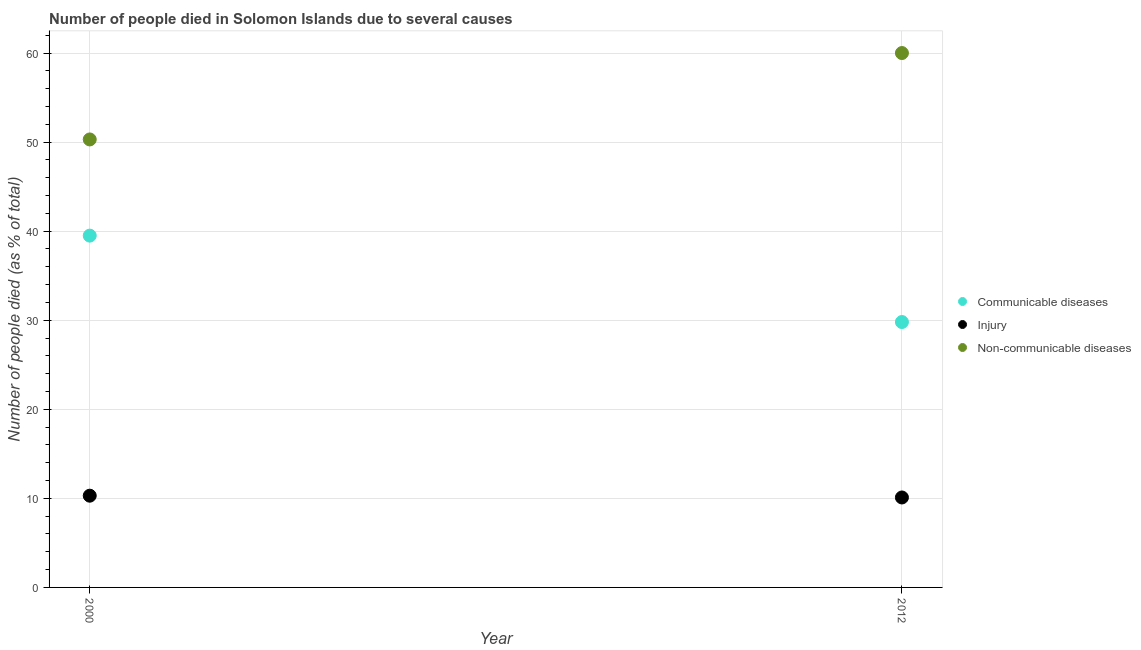How many different coloured dotlines are there?
Ensure brevity in your answer.  3. Is the number of dotlines equal to the number of legend labels?
Keep it short and to the point. Yes. What is the number of people who dies of non-communicable diseases in 2000?
Your answer should be very brief. 50.3. Across all years, what is the maximum number of people who died of injury?
Your answer should be compact. 10.3. Across all years, what is the minimum number of people who died of injury?
Provide a short and direct response. 10.1. In which year was the number of people who died of injury maximum?
Make the answer very short. 2000. In which year was the number of people who died of communicable diseases minimum?
Your answer should be very brief. 2012. What is the total number of people who died of injury in the graph?
Provide a succinct answer. 20.4. What is the difference between the number of people who died of injury in 2000 and that in 2012?
Ensure brevity in your answer.  0.2. What is the average number of people who dies of non-communicable diseases per year?
Provide a short and direct response. 55.15. In the year 2000, what is the difference between the number of people who died of communicable diseases and number of people who dies of non-communicable diseases?
Keep it short and to the point. -10.8. In how many years, is the number of people who dies of non-communicable diseases greater than 34 %?
Keep it short and to the point. 2. What is the ratio of the number of people who died of injury in 2000 to that in 2012?
Your response must be concise. 1.02. Is the number of people who dies of non-communicable diseases in 2000 less than that in 2012?
Your answer should be very brief. Yes. Is it the case that in every year, the sum of the number of people who died of communicable diseases and number of people who died of injury is greater than the number of people who dies of non-communicable diseases?
Keep it short and to the point. No. Does the number of people who dies of non-communicable diseases monotonically increase over the years?
Provide a short and direct response. Yes. Is the number of people who dies of non-communicable diseases strictly greater than the number of people who died of injury over the years?
Your response must be concise. Yes. How many dotlines are there?
Your response must be concise. 3. How many years are there in the graph?
Your response must be concise. 2. Does the graph contain any zero values?
Give a very brief answer. No. How many legend labels are there?
Your answer should be compact. 3. What is the title of the graph?
Keep it short and to the point. Number of people died in Solomon Islands due to several causes. Does "Coal sources" appear as one of the legend labels in the graph?
Ensure brevity in your answer.  No. What is the label or title of the X-axis?
Your answer should be compact. Year. What is the label or title of the Y-axis?
Make the answer very short. Number of people died (as % of total). What is the Number of people died (as % of total) in Communicable diseases in 2000?
Provide a succinct answer. 39.5. What is the Number of people died (as % of total) of Injury in 2000?
Your answer should be very brief. 10.3. What is the Number of people died (as % of total) in Non-communicable diseases in 2000?
Provide a short and direct response. 50.3. What is the Number of people died (as % of total) of Communicable diseases in 2012?
Provide a short and direct response. 29.8. Across all years, what is the maximum Number of people died (as % of total) of Communicable diseases?
Provide a short and direct response. 39.5. Across all years, what is the maximum Number of people died (as % of total) of Injury?
Provide a succinct answer. 10.3. Across all years, what is the maximum Number of people died (as % of total) of Non-communicable diseases?
Ensure brevity in your answer.  60. Across all years, what is the minimum Number of people died (as % of total) in Communicable diseases?
Your answer should be compact. 29.8. Across all years, what is the minimum Number of people died (as % of total) of Non-communicable diseases?
Provide a succinct answer. 50.3. What is the total Number of people died (as % of total) in Communicable diseases in the graph?
Your answer should be compact. 69.3. What is the total Number of people died (as % of total) of Injury in the graph?
Your response must be concise. 20.4. What is the total Number of people died (as % of total) in Non-communicable diseases in the graph?
Keep it short and to the point. 110.3. What is the difference between the Number of people died (as % of total) of Communicable diseases in 2000 and that in 2012?
Offer a terse response. 9.7. What is the difference between the Number of people died (as % of total) of Injury in 2000 and that in 2012?
Keep it short and to the point. 0.2. What is the difference between the Number of people died (as % of total) in Communicable diseases in 2000 and the Number of people died (as % of total) in Injury in 2012?
Give a very brief answer. 29.4. What is the difference between the Number of people died (as % of total) of Communicable diseases in 2000 and the Number of people died (as % of total) of Non-communicable diseases in 2012?
Provide a succinct answer. -20.5. What is the difference between the Number of people died (as % of total) of Injury in 2000 and the Number of people died (as % of total) of Non-communicable diseases in 2012?
Offer a very short reply. -49.7. What is the average Number of people died (as % of total) of Communicable diseases per year?
Your answer should be very brief. 34.65. What is the average Number of people died (as % of total) of Injury per year?
Keep it short and to the point. 10.2. What is the average Number of people died (as % of total) of Non-communicable diseases per year?
Make the answer very short. 55.15. In the year 2000, what is the difference between the Number of people died (as % of total) of Communicable diseases and Number of people died (as % of total) of Injury?
Provide a succinct answer. 29.2. In the year 2000, what is the difference between the Number of people died (as % of total) of Injury and Number of people died (as % of total) of Non-communicable diseases?
Your answer should be compact. -40. In the year 2012, what is the difference between the Number of people died (as % of total) of Communicable diseases and Number of people died (as % of total) of Injury?
Offer a terse response. 19.7. In the year 2012, what is the difference between the Number of people died (as % of total) in Communicable diseases and Number of people died (as % of total) in Non-communicable diseases?
Your answer should be compact. -30.2. In the year 2012, what is the difference between the Number of people died (as % of total) in Injury and Number of people died (as % of total) in Non-communicable diseases?
Ensure brevity in your answer.  -49.9. What is the ratio of the Number of people died (as % of total) in Communicable diseases in 2000 to that in 2012?
Give a very brief answer. 1.33. What is the ratio of the Number of people died (as % of total) of Injury in 2000 to that in 2012?
Ensure brevity in your answer.  1.02. What is the ratio of the Number of people died (as % of total) of Non-communicable diseases in 2000 to that in 2012?
Provide a short and direct response. 0.84. What is the difference between the highest and the second highest Number of people died (as % of total) in Injury?
Make the answer very short. 0.2. What is the difference between the highest and the lowest Number of people died (as % of total) in Non-communicable diseases?
Give a very brief answer. 9.7. 